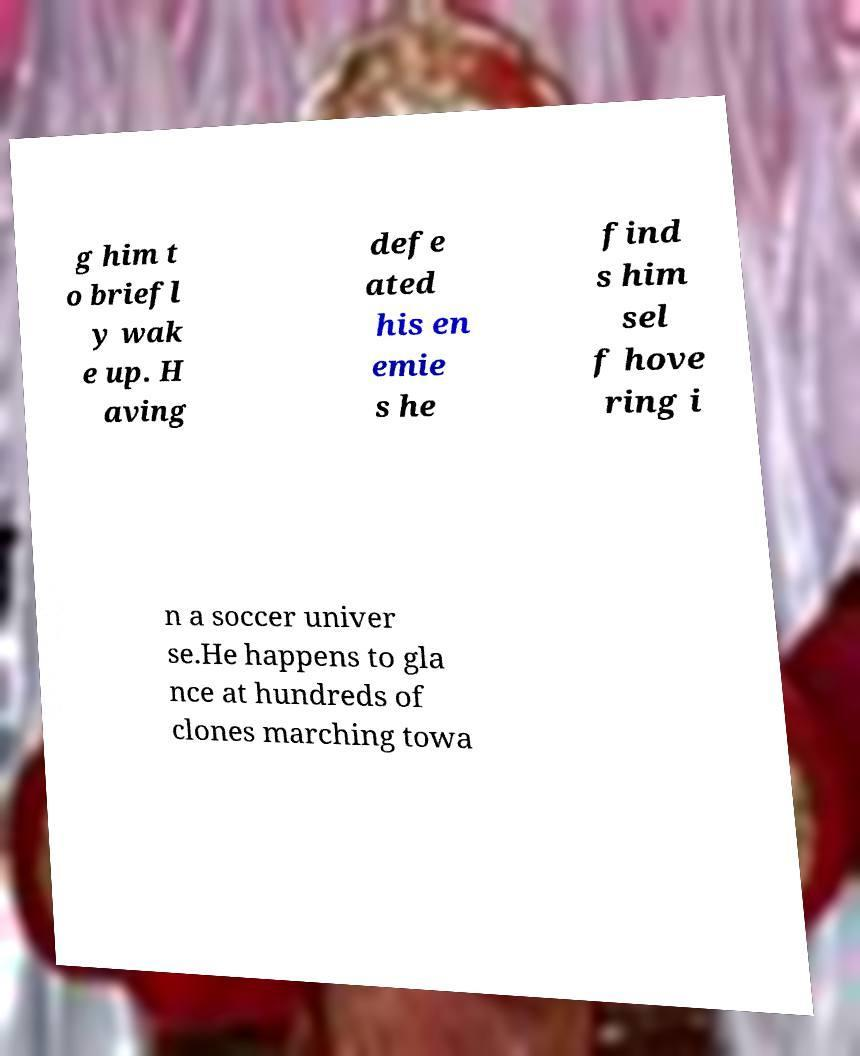Can you read and provide the text displayed in the image?This photo seems to have some interesting text. Can you extract and type it out for me? g him t o briefl y wak e up. H aving defe ated his en emie s he find s him sel f hove ring i n a soccer univer se.He happens to gla nce at hundreds of clones marching towa 